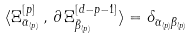Convert formula to latex. <formula><loc_0><loc_0><loc_500><loc_500>\langle { \Xi } ^ { [ p ] } _ { \bar { \alpha } _ { ( p ) } } \, , \, \partial \, { \Xi } ^ { [ d - p - 1 ] } _ { \bar { \beta } _ { ( p ) } } \rangle = \delta _ { \bar { \alpha } _ { ( p ) } \bar { \beta } _ { ( p ) } }</formula> 